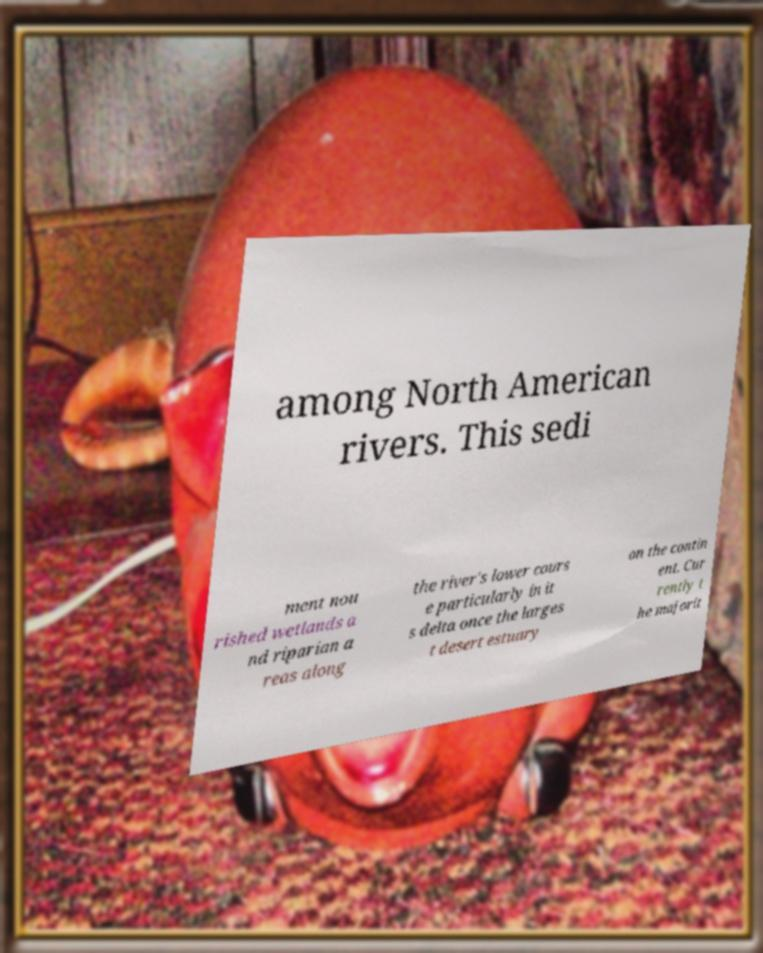Can you accurately transcribe the text from the provided image for me? among North American rivers. This sedi ment nou rished wetlands a nd riparian a reas along the river's lower cours e particularly in it s delta once the larges t desert estuary on the contin ent. Cur rently t he majorit 